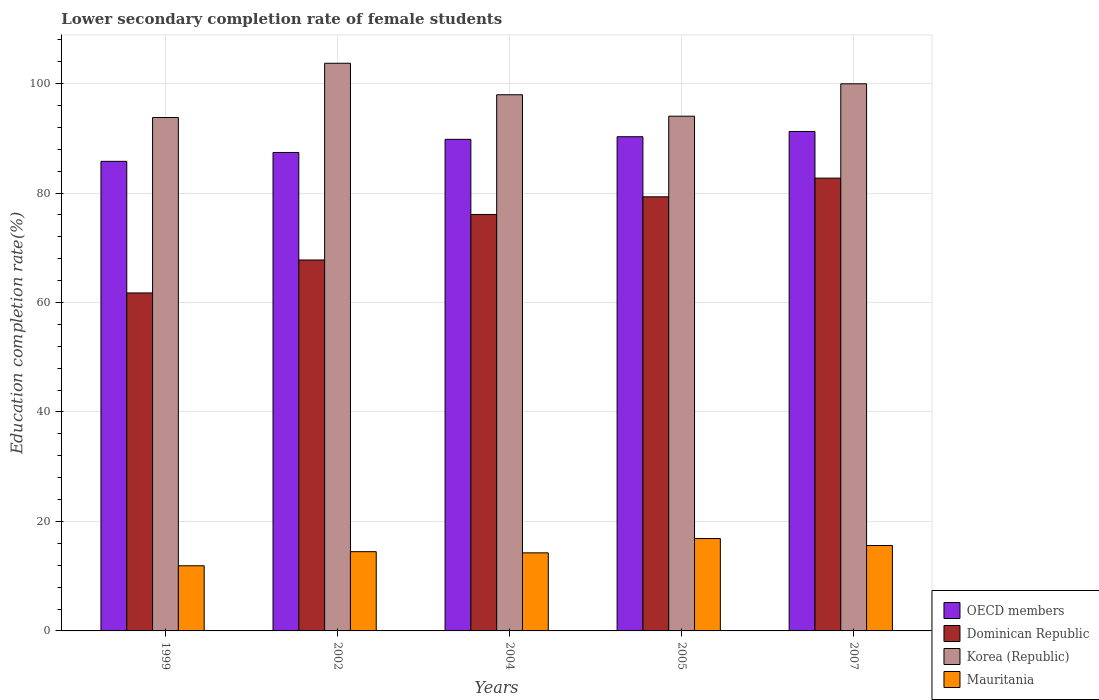Are the number of bars per tick equal to the number of legend labels?
Provide a short and direct response. Yes. How many bars are there on the 3rd tick from the left?
Your answer should be very brief. 4. How many bars are there on the 3rd tick from the right?
Give a very brief answer. 4. What is the label of the 1st group of bars from the left?
Your answer should be very brief. 1999. In how many cases, is the number of bars for a given year not equal to the number of legend labels?
Your response must be concise. 0. What is the lower secondary completion rate of female students in Korea (Republic) in 2005?
Your answer should be compact. 94.05. Across all years, what is the maximum lower secondary completion rate of female students in Mauritania?
Keep it short and to the point. 16.88. Across all years, what is the minimum lower secondary completion rate of female students in Mauritania?
Your answer should be compact. 11.9. What is the total lower secondary completion rate of female students in OECD members in the graph?
Give a very brief answer. 444.58. What is the difference between the lower secondary completion rate of female students in Mauritania in 1999 and that in 2004?
Keep it short and to the point. -2.36. What is the difference between the lower secondary completion rate of female students in Mauritania in 2005 and the lower secondary completion rate of female students in Dominican Republic in 1999?
Make the answer very short. -44.88. What is the average lower secondary completion rate of female students in OECD members per year?
Your response must be concise. 88.92. In the year 2007, what is the difference between the lower secondary completion rate of female students in Mauritania and lower secondary completion rate of female students in Dominican Republic?
Provide a succinct answer. -67.13. What is the ratio of the lower secondary completion rate of female students in Dominican Republic in 2002 to that in 2004?
Your response must be concise. 0.89. Is the lower secondary completion rate of female students in Korea (Republic) in 2002 less than that in 2007?
Ensure brevity in your answer.  No. What is the difference between the highest and the second highest lower secondary completion rate of female students in OECD members?
Offer a very short reply. 0.96. What is the difference between the highest and the lowest lower secondary completion rate of female students in Korea (Republic)?
Give a very brief answer. 9.91. What does the 1st bar from the left in 2002 represents?
Your response must be concise. OECD members. What does the 1st bar from the right in 2004 represents?
Provide a succinct answer. Mauritania. Are all the bars in the graph horizontal?
Your answer should be compact. No. How many years are there in the graph?
Offer a very short reply. 5. Are the values on the major ticks of Y-axis written in scientific E-notation?
Your answer should be very brief. No. Does the graph contain any zero values?
Provide a succinct answer. No. How many legend labels are there?
Give a very brief answer. 4. How are the legend labels stacked?
Offer a very short reply. Vertical. What is the title of the graph?
Provide a short and direct response. Lower secondary completion rate of female students. What is the label or title of the Y-axis?
Make the answer very short. Education completion rate(%). What is the Education completion rate(%) in OECD members in 1999?
Ensure brevity in your answer.  85.8. What is the Education completion rate(%) of Dominican Republic in 1999?
Ensure brevity in your answer.  61.75. What is the Education completion rate(%) of Korea (Republic) in 1999?
Give a very brief answer. 93.8. What is the Education completion rate(%) in Mauritania in 1999?
Ensure brevity in your answer.  11.9. What is the Education completion rate(%) of OECD members in 2002?
Make the answer very short. 87.42. What is the Education completion rate(%) of Dominican Republic in 2002?
Ensure brevity in your answer.  67.77. What is the Education completion rate(%) of Korea (Republic) in 2002?
Offer a very short reply. 103.72. What is the Education completion rate(%) of Mauritania in 2002?
Make the answer very short. 14.48. What is the Education completion rate(%) in OECD members in 2004?
Offer a terse response. 89.82. What is the Education completion rate(%) in Dominican Republic in 2004?
Your answer should be compact. 76.09. What is the Education completion rate(%) of Korea (Republic) in 2004?
Give a very brief answer. 97.96. What is the Education completion rate(%) in Mauritania in 2004?
Give a very brief answer. 14.26. What is the Education completion rate(%) of OECD members in 2005?
Provide a succinct answer. 90.29. What is the Education completion rate(%) of Dominican Republic in 2005?
Your answer should be compact. 79.31. What is the Education completion rate(%) of Korea (Republic) in 2005?
Your response must be concise. 94.05. What is the Education completion rate(%) in Mauritania in 2005?
Provide a short and direct response. 16.88. What is the Education completion rate(%) in OECD members in 2007?
Your answer should be compact. 91.25. What is the Education completion rate(%) of Dominican Republic in 2007?
Your answer should be compact. 82.73. What is the Education completion rate(%) in Korea (Republic) in 2007?
Provide a succinct answer. 99.96. What is the Education completion rate(%) in Mauritania in 2007?
Keep it short and to the point. 15.6. Across all years, what is the maximum Education completion rate(%) of OECD members?
Provide a short and direct response. 91.25. Across all years, what is the maximum Education completion rate(%) in Dominican Republic?
Your response must be concise. 82.73. Across all years, what is the maximum Education completion rate(%) of Korea (Republic)?
Your response must be concise. 103.72. Across all years, what is the maximum Education completion rate(%) of Mauritania?
Keep it short and to the point. 16.88. Across all years, what is the minimum Education completion rate(%) of OECD members?
Offer a very short reply. 85.8. Across all years, what is the minimum Education completion rate(%) of Dominican Republic?
Provide a succinct answer. 61.75. Across all years, what is the minimum Education completion rate(%) of Korea (Republic)?
Give a very brief answer. 93.8. Across all years, what is the minimum Education completion rate(%) in Mauritania?
Your response must be concise. 11.9. What is the total Education completion rate(%) of OECD members in the graph?
Your answer should be compact. 444.58. What is the total Education completion rate(%) of Dominican Republic in the graph?
Offer a terse response. 367.66. What is the total Education completion rate(%) in Korea (Republic) in the graph?
Your answer should be compact. 489.49. What is the total Education completion rate(%) in Mauritania in the graph?
Keep it short and to the point. 73.12. What is the difference between the Education completion rate(%) of OECD members in 1999 and that in 2002?
Give a very brief answer. -1.62. What is the difference between the Education completion rate(%) in Dominican Republic in 1999 and that in 2002?
Make the answer very short. -6.02. What is the difference between the Education completion rate(%) of Korea (Republic) in 1999 and that in 2002?
Keep it short and to the point. -9.91. What is the difference between the Education completion rate(%) in Mauritania in 1999 and that in 2002?
Keep it short and to the point. -2.58. What is the difference between the Education completion rate(%) in OECD members in 1999 and that in 2004?
Keep it short and to the point. -4.02. What is the difference between the Education completion rate(%) of Dominican Republic in 1999 and that in 2004?
Offer a very short reply. -14.34. What is the difference between the Education completion rate(%) in Korea (Republic) in 1999 and that in 2004?
Offer a very short reply. -4.16. What is the difference between the Education completion rate(%) of Mauritania in 1999 and that in 2004?
Ensure brevity in your answer.  -2.36. What is the difference between the Education completion rate(%) in OECD members in 1999 and that in 2005?
Your answer should be compact. -4.5. What is the difference between the Education completion rate(%) in Dominican Republic in 1999 and that in 2005?
Provide a succinct answer. -17.56. What is the difference between the Education completion rate(%) in Korea (Republic) in 1999 and that in 2005?
Give a very brief answer. -0.24. What is the difference between the Education completion rate(%) of Mauritania in 1999 and that in 2005?
Provide a succinct answer. -4.97. What is the difference between the Education completion rate(%) in OECD members in 1999 and that in 2007?
Ensure brevity in your answer.  -5.46. What is the difference between the Education completion rate(%) of Dominican Republic in 1999 and that in 2007?
Make the answer very short. -20.98. What is the difference between the Education completion rate(%) of Korea (Republic) in 1999 and that in 2007?
Your response must be concise. -6.16. What is the difference between the Education completion rate(%) of Mauritania in 1999 and that in 2007?
Give a very brief answer. -3.7. What is the difference between the Education completion rate(%) of OECD members in 2002 and that in 2004?
Give a very brief answer. -2.4. What is the difference between the Education completion rate(%) in Dominican Republic in 2002 and that in 2004?
Offer a very short reply. -8.32. What is the difference between the Education completion rate(%) in Korea (Republic) in 2002 and that in 2004?
Provide a succinct answer. 5.75. What is the difference between the Education completion rate(%) of Mauritania in 2002 and that in 2004?
Provide a short and direct response. 0.22. What is the difference between the Education completion rate(%) of OECD members in 2002 and that in 2005?
Offer a very short reply. -2.88. What is the difference between the Education completion rate(%) of Dominican Republic in 2002 and that in 2005?
Keep it short and to the point. -11.54. What is the difference between the Education completion rate(%) in Korea (Republic) in 2002 and that in 2005?
Keep it short and to the point. 9.67. What is the difference between the Education completion rate(%) in Mauritania in 2002 and that in 2005?
Your response must be concise. -2.4. What is the difference between the Education completion rate(%) of OECD members in 2002 and that in 2007?
Your answer should be very brief. -3.84. What is the difference between the Education completion rate(%) in Dominican Republic in 2002 and that in 2007?
Make the answer very short. -14.96. What is the difference between the Education completion rate(%) in Korea (Republic) in 2002 and that in 2007?
Ensure brevity in your answer.  3.75. What is the difference between the Education completion rate(%) in Mauritania in 2002 and that in 2007?
Your answer should be very brief. -1.12. What is the difference between the Education completion rate(%) of OECD members in 2004 and that in 2005?
Your answer should be compact. -0.48. What is the difference between the Education completion rate(%) in Dominican Republic in 2004 and that in 2005?
Give a very brief answer. -3.23. What is the difference between the Education completion rate(%) in Korea (Republic) in 2004 and that in 2005?
Your answer should be very brief. 3.92. What is the difference between the Education completion rate(%) of Mauritania in 2004 and that in 2005?
Your answer should be compact. -2.61. What is the difference between the Education completion rate(%) in OECD members in 2004 and that in 2007?
Your answer should be compact. -1.44. What is the difference between the Education completion rate(%) in Dominican Republic in 2004 and that in 2007?
Offer a terse response. -6.64. What is the difference between the Education completion rate(%) of Korea (Republic) in 2004 and that in 2007?
Keep it short and to the point. -2. What is the difference between the Education completion rate(%) in Mauritania in 2004 and that in 2007?
Your response must be concise. -1.34. What is the difference between the Education completion rate(%) of OECD members in 2005 and that in 2007?
Your response must be concise. -0.96. What is the difference between the Education completion rate(%) of Dominican Republic in 2005 and that in 2007?
Your answer should be compact. -3.42. What is the difference between the Education completion rate(%) in Korea (Republic) in 2005 and that in 2007?
Ensure brevity in your answer.  -5.92. What is the difference between the Education completion rate(%) in Mauritania in 2005 and that in 2007?
Make the answer very short. 1.27. What is the difference between the Education completion rate(%) of OECD members in 1999 and the Education completion rate(%) of Dominican Republic in 2002?
Offer a very short reply. 18.02. What is the difference between the Education completion rate(%) in OECD members in 1999 and the Education completion rate(%) in Korea (Republic) in 2002?
Keep it short and to the point. -17.92. What is the difference between the Education completion rate(%) of OECD members in 1999 and the Education completion rate(%) of Mauritania in 2002?
Give a very brief answer. 71.32. What is the difference between the Education completion rate(%) of Dominican Republic in 1999 and the Education completion rate(%) of Korea (Republic) in 2002?
Give a very brief answer. -41.96. What is the difference between the Education completion rate(%) in Dominican Republic in 1999 and the Education completion rate(%) in Mauritania in 2002?
Ensure brevity in your answer.  47.27. What is the difference between the Education completion rate(%) in Korea (Republic) in 1999 and the Education completion rate(%) in Mauritania in 2002?
Your answer should be compact. 79.32. What is the difference between the Education completion rate(%) in OECD members in 1999 and the Education completion rate(%) in Dominican Republic in 2004?
Offer a terse response. 9.71. What is the difference between the Education completion rate(%) in OECD members in 1999 and the Education completion rate(%) in Korea (Republic) in 2004?
Offer a very short reply. -12.17. What is the difference between the Education completion rate(%) of OECD members in 1999 and the Education completion rate(%) of Mauritania in 2004?
Provide a short and direct response. 71.53. What is the difference between the Education completion rate(%) in Dominican Republic in 1999 and the Education completion rate(%) in Korea (Republic) in 2004?
Ensure brevity in your answer.  -36.21. What is the difference between the Education completion rate(%) in Dominican Republic in 1999 and the Education completion rate(%) in Mauritania in 2004?
Your response must be concise. 47.49. What is the difference between the Education completion rate(%) in Korea (Republic) in 1999 and the Education completion rate(%) in Mauritania in 2004?
Give a very brief answer. 79.54. What is the difference between the Education completion rate(%) in OECD members in 1999 and the Education completion rate(%) in Dominican Republic in 2005?
Offer a terse response. 6.48. What is the difference between the Education completion rate(%) of OECD members in 1999 and the Education completion rate(%) of Korea (Republic) in 2005?
Provide a succinct answer. -8.25. What is the difference between the Education completion rate(%) in OECD members in 1999 and the Education completion rate(%) in Mauritania in 2005?
Ensure brevity in your answer.  68.92. What is the difference between the Education completion rate(%) in Dominican Republic in 1999 and the Education completion rate(%) in Korea (Republic) in 2005?
Offer a very short reply. -32.29. What is the difference between the Education completion rate(%) in Dominican Republic in 1999 and the Education completion rate(%) in Mauritania in 2005?
Ensure brevity in your answer.  44.88. What is the difference between the Education completion rate(%) in Korea (Republic) in 1999 and the Education completion rate(%) in Mauritania in 2005?
Your answer should be compact. 76.93. What is the difference between the Education completion rate(%) in OECD members in 1999 and the Education completion rate(%) in Dominican Republic in 2007?
Keep it short and to the point. 3.07. What is the difference between the Education completion rate(%) of OECD members in 1999 and the Education completion rate(%) of Korea (Republic) in 2007?
Ensure brevity in your answer.  -14.17. What is the difference between the Education completion rate(%) in OECD members in 1999 and the Education completion rate(%) in Mauritania in 2007?
Provide a short and direct response. 70.19. What is the difference between the Education completion rate(%) in Dominican Republic in 1999 and the Education completion rate(%) in Korea (Republic) in 2007?
Make the answer very short. -38.21. What is the difference between the Education completion rate(%) in Dominican Republic in 1999 and the Education completion rate(%) in Mauritania in 2007?
Keep it short and to the point. 46.15. What is the difference between the Education completion rate(%) of Korea (Republic) in 1999 and the Education completion rate(%) of Mauritania in 2007?
Your response must be concise. 78.2. What is the difference between the Education completion rate(%) of OECD members in 2002 and the Education completion rate(%) of Dominican Republic in 2004?
Your answer should be compact. 11.33. What is the difference between the Education completion rate(%) in OECD members in 2002 and the Education completion rate(%) in Korea (Republic) in 2004?
Your response must be concise. -10.55. What is the difference between the Education completion rate(%) of OECD members in 2002 and the Education completion rate(%) of Mauritania in 2004?
Give a very brief answer. 73.15. What is the difference between the Education completion rate(%) in Dominican Republic in 2002 and the Education completion rate(%) in Korea (Republic) in 2004?
Ensure brevity in your answer.  -30.19. What is the difference between the Education completion rate(%) of Dominican Republic in 2002 and the Education completion rate(%) of Mauritania in 2004?
Offer a terse response. 53.51. What is the difference between the Education completion rate(%) in Korea (Republic) in 2002 and the Education completion rate(%) in Mauritania in 2004?
Offer a terse response. 89.45. What is the difference between the Education completion rate(%) of OECD members in 2002 and the Education completion rate(%) of Dominican Republic in 2005?
Offer a terse response. 8.1. What is the difference between the Education completion rate(%) in OECD members in 2002 and the Education completion rate(%) in Korea (Republic) in 2005?
Make the answer very short. -6.63. What is the difference between the Education completion rate(%) in OECD members in 2002 and the Education completion rate(%) in Mauritania in 2005?
Provide a succinct answer. 70.54. What is the difference between the Education completion rate(%) of Dominican Republic in 2002 and the Education completion rate(%) of Korea (Republic) in 2005?
Provide a succinct answer. -26.27. What is the difference between the Education completion rate(%) of Dominican Republic in 2002 and the Education completion rate(%) of Mauritania in 2005?
Keep it short and to the point. 50.9. What is the difference between the Education completion rate(%) of Korea (Republic) in 2002 and the Education completion rate(%) of Mauritania in 2005?
Provide a short and direct response. 86.84. What is the difference between the Education completion rate(%) of OECD members in 2002 and the Education completion rate(%) of Dominican Republic in 2007?
Your answer should be very brief. 4.69. What is the difference between the Education completion rate(%) in OECD members in 2002 and the Education completion rate(%) in Korea (Republic) in 2007?
Your response must be concise. -12.55. What is the difference between the Education completion rate(%) in OECD members in 2002 and the Education completion rate(%) in Mauritania in 2007?
Your response must be concise. 71.82. What is the difference between the Education completion rate(%) in Dominican Republic in 2002 and the Education completion rate(%) in Korea (Republic) in 2007?
Your answer should be compact. -32.19. What is the difference between the Education completion rate(%) of Dominican Republic in 2002 and the Education completion rate(%) of Mauritania in 2007?
Provide a succinct answer. 52.17. What is the difference between the Education completion rate(%) in Korea (Republic) in 2002 and the Education completion rate(%) in Mauritania in 2007?
Provide a short and direct response. 88.12. What is the difference between the Education completion rate(%) in OECD members in 2004 and the Education completion rate(%) in Dominican Republic in 2005?
Give a very brief answer. 10.5. What is the difference between the Education completion rate(%) of OECD members in 2004 and the Education completion rate(%) of Korea (Republic) in 2005?
Provide a succinct answer. -4.23. What is the difference between the Education completion rate(%) in OECD members in 2004 and the Education completion rate(%) in Mauritania in 2005?
Ensure brevity in your answer.  72.94. What is the difference between the Education completion rate(%) in Dominican Republic in 2004 and the Education completion rate(%) in Korea (Republic) in 2005?
Offer a terse response. -17.96. What is the difference between the Education completion rate(%) in Dominican Republic in 2004 and the Education completion rate(%) in Mauritania in 2005?
Your answer should be very brief. 59.21. What is the difference between the Education completion rate(%) in Korea (Republic) in 2004 and the Education completion rate(%) in Mauritania in 2005?
Offer a terse response. 81.09. What is the difference between the Education completion rate(%) in OECD members in 2004 and the Education completion rate(%) in Dominican Republic in 2007?
Your answer should be compact. 7.09. What is the difference between the Education completion rate(%) of OECD members in 2004 and the Education completion rate(%) of Korea (Republic) in 2007?
Your answer should be very brief. -10.15. What is the difference between the Education completion rate(%) of OECD members in 2004 and the Education completion rate(%) of Mauritania in 2007?
Provide a short and direct response. 74.21. What is the difference between the Education completion rate(%) in Dominican Republic in 2004 and the Education completion rate(%) in Korea (Republic) in 2007?
Make the answer very short. -23.87. What is the difference between the Education completion rate(%) in Dominican Republic in 2004 and the Education completion rate(%) in Mauritania in 2007?
Provide a succinct answer. 60.49. What is the difference between the Education completion rate(%) in Korea (Republic) in 2004 and the Education completion rate(%) in Mauritania in 2007?
Make the answer very short. 82.36. What is the difference between the Education completion rate(%) of OECD members in 2005 and the Education completion rate(%) of Dominican Republic in 2007?
Provide a short and direct response. 7.56. What is the difference between the Education completion rate(%) in OECD members in 2005 and the Education completion rate(%) in Korea (Republic) in 2007?
Your answer should be compact. -9.67. What is the difference between the Education completion rate(%) of OECD members in 2005 and the Education completion rate(%) of Mauritania in 2007?
Offer a terse response. 74.69. What is the difference between the Education completion rate(%) in Dominican Republic in 2005 and the Education completion rate(%) in Korea (Republic) in 2007?
Your answer should be compact. -20.65. What is the difference between the Education completion rate(%) in Dominican Republic in 2005 and the Education completion rate(%) in Mauritania in 2007?
Offer a terse response. 63.71. What is the difference between the Education completion rate(%) of Korea (Republic) in 2005 and the Education completion rate(%) of Mauritania in 2007?
Offer a terse response. 78.44. What is the average Education completion rate(%) in OECD members per year?
Keep it short and to the point. 88.92. What is the average Education completion rate(%) in Dominican Republic per year?
Provide a short and direct response. 73.53. What is the average Education completion rate(%) in Korea (Republic) per year?
Your answer should be very brief. 97.9. What is the average Education completion rate(%) in Mauritania per year?
Provide a short and direct response. 14.62. In the year 1999, what is the difference between the Education completion rate(%) of OECD members and Education completion rate(%) of Dominican Republic?
Keep it short and to the point. 24.04. In the year 1999, what is the difference between the Education completion rate(%) of OECD members and Education completion rate(%) of Korea (Republic)?
Your answer should be compact. -8.01. In the year 1999, what is the difference between the Education completion rate(%) in OECD members and Education completion rate(%) in Mauritania?
Your response must be concise. 73.89. In the year 1999, what is the difference between the Education completion rate(%) in Dominican Republic and Education completion rate(%) in Korea (Republic)?
Offer a very short reply. -32.05. In the year 1999, what is the difference between the Education completion rate(%) of Dominican Republic and Education completion rate(%) of Mauritania?
Your response must be concise. 49.85. In the year 1999, what is the difference between the Education completion rate(%) in Korea (Republic) and Education completion rate(%) in Mauritania?
Offer a very short reply. 81.9. In the year 2002, what is the difference between the Education completion rate(%) of OECD members and Education completion rate(%) of Dominican Republic?
Provide a short and direct response. 19.65. In the year 2002, what is the difference between the Education completion rate(%) in OECD members and Education completion rate(%) in Korea (Republic)?
Make the answer very short. -16.3. In the year 2002, what is the difference between the Education completion rate(%) of OECD members and Education completion rate(%) of Mauritania?
Offer a terse response. 72.94. In the year 2002, what is the difference between the Education completion rate(%) in Dominican Republic and Education completion rate(%) in Korea (Republic)?
Ensure brevity in your answer.  -35.95. In the year 2002, what is the difference between the Education completion rate(%) in Dominican Republic and Education completion rate(%) in Mauritania?
Give a very brief answer. 53.29. In the year 2002, what is the difference between the Education completion rate(%) of Korea (Republic) and Education completion rate(%) of Mauritania?
Provide a succinct answer. 89.24. In the year 2004, what is the difference between the Education completion rate(%) of OECD members and Education completion rate(%) of Dominican Republic?
Your response must be concise. 13.73. In the year 2004, what is the difference between the Education completion rate(%) in OECD members and Education completion rate(%) in Korea (Republic)?
Offer a terse response. -8.15. In the year 2004, what is the difference between the Education completion rate(%) in OECD members and Education completion rate(%) in Mauritania?
Ensure brevity in your answer.  75.55. In the year 2004, what is the difference between the Education completion rate(%) of Dominican Republic and Education completion rate(%) of Korea (Republic)?
Your answer should be compact. -21.87. In the year 2004, what is the difference between the Education completion rate(%) in Dominican Republic and Education completion rate(%) in Mauritania?
Provide a short and direct response. 61.83. In the year 2004, what is the difference between the Education completion rate(%) in Korea (Republic) and Education completion rate(%) in Mauritania?
Your answer should be compact. 83.7. In the year 2005, what is the difference between the Education completion rate(%) of OECD members and Education completion rate(%) of Dominican Republic?
Offer a very short reply. 10.98. In the year 2005, what is the difference between the Education completion rate(%) of OECD members and Education completion rate(%) of Korea (Republic)?
Your response must be concise. -3.75. In the year 2005, what is the difference between the Education completion rate(%) in OECD members and Education completion rate(%) in Mauritania?
Offer a terse response. 73.42. In the year 2005, what is the difference between the Education completion rate(%) in Dominican Republic and Education completion rate(%) in Korea (Republic)?
Your response must be concise. -14.73. In the year 2005, what is the difference between the Education completion rate(%) of Dominican Republic and Education completion rate(%) of Mauritania?
Provide a short and direct response. 62.44. In the year 2005, what is the difference between the Education completion rate(%) of Korea (Republic) and Education completion rate(%) of Mauritania?
Provide a succinct answer. 77.17. In the year 2007, what is the difference between the Education completion rate(%) in OECD members and Education completion rate(%) in Dominican Republic?
Your answer should be compact. 8.52. In the year 2007, what is the difference between the Education completion rate(%) of OECD members and Education completion rate(%) of Korea (Republic)?
Offer a terse response. -8.71. In the year 2007, what is the difference between the Education completion rate(%) of OECD members and Education completion rate(%) of Mauritania?
Make the answer very short. 75.65. In the year 2007, what is the difference between the Education completion rate(%) in Dominican Republic and Education completion rate(%) in Korea (Republic)?
Your answer should be compact. -17.23. In the year 2007, what is the difference between the Education completion rate(%) of Dominican Republic and Education completion rate(%) of Mauritania?
Keep it short and to the point. 67.13. In the year 2007, what is the difference between the Education completion rate(%) of Korea (Republic) and Education completion rate(%) of Mauritania?
Your answer should be very brief. 84.36. What is the ratio of the Education completion rate(%) of OECD members in 1999 to that in 2002?
Provide a succinct answer. 0.98. What is the ratio of the Education completion rate(%) of Dominican Republic in 1999 to that in 2002?
Offer a very short reply. 0.91. What is the ratio of the Education completion rate(%) of Korea (Republic) in 1999 to that in 2002?
Offer a very short reply. 0.9. What is the ratio of the Education completion rate(%) of Mauritania in 1999 to that in 2002?
Keep it short and to the point. 0.82. What is the ratio of the Education completion rate(%) in OECD members in 1999 to that in 2004?
Ensure brevity in your answer.  0.96. What is the ratio of the Education completion rate(%) in Dominican Republic in 1999 to that in 2004?
Make the answer very short. 0.81. What is the ratio of the Education completion rate(%) of Korea (Republic) in 1999 to that in 2004?
Your answer should be compact. 0.96. What is the ratio of the Education completion rate(%) of Mauritania in 1999 to that in 2004?
Provide a short and direct response. 0.83. What is the ratio of the Education completion rate(%) of OECD members in 1999 to that in 2005?
Your response must be concise. 0.95. What is the ratio of the Education completion rate(%) of Dominican Republic in 1999 to that in 2005?
Provide a succinct answer. 0.78. What is the ratio of the Education completion rate(%) in Korea (Republic) in 1999 to that in 2005?
Give a very brief answer. 1. What is the ratio of the Education completion rate(%) in Mauritania in 1999 to that in 2005?
Keep it short and to the point. 0.71. What is the ratio of the Education completion rate(%) of OECD members in 1999 to that in 2007?
Give a very brief answer. 0.94. What is the ratio of the Education completion rate(%) of Dominican Republic in 1999 to that in 2007?
Give a very brief answer. 0.75. What is the ratio of the Education completion rate(%) in Korea (Republic) in 1999 to that in 2007?
Give a very brief answer. 0.94. What is the ratio of the Education completion rate(%) in Mauritania in 1999 to that in 2007?
Ensure brevity in your answer.  0.76. What is the ratio of the Education completion rate(%) of OECD members in 2002 to that in 2004?
Your answer should be very brief. 0.97. What is the ratio of the Education completion rate(%) of Dominican Republic in 2002 to that in 2004?
Provide a succinct answer. 0.89. What is the ratio of the Education completion rate(%) of Korea (Republic) in 2002 to that in 2004?
Your response must be concise. 1.06. What is the ratio of the Education completion rate(%) in Mauritania in 2002 to that in 2004?
Provide a short and direct response. 1.02. What is the ratio of the Education completion rate(%) in OECD members in 2002 to that in 2005?
Provide a short and direct response. 0.97. What is the ratio of the Education completion rate(%) in Dominican Republic in 2002 to that in 2005?
Your answer should be compact. 0.85. What is the ratio of the Education completion rate(%) of Korea (Republic) in 2002 to that in 2005?
Ensure brevity in your answer.  1.1. What is the ratio of the Education completion rate(%) of Mauritania in 2002 to that in 2005?
Provide a short and direct response. 0.86. What is the ratio of the Education completion rate(%) in OECD members in 2002 to that in 2007?
Make the answer very short. 0.96. What is the ratio of the Education completion rate(%) in Dominican Republic in 2002 to that in 2007?
Give a very brief answer. 0.82. What is the ratio of the Education completion rate(%) of Korea (Republic) in 2002 to that in 2007?
Give a very brief answer. 1.04. What is the ratio of the Education completion rate(%) of Mauritania in 2002 to that in 2007?
Ensure brevity in your answer.  0.93. What is the ratio of the Education completion rate(%) in Dominican Republic in 2004 to that in 2005?
Offer a very short reply. 0.96. What is the ratio of the Education completion rate(%) of Korea (Republic) in 2004 to that in 2005?
Provide a succinct answer. 1.04. What is the ratio of the Education completion rate(%) of Mauritania in 2004 to that in 2005?
Offer a very short reply. 0.85. What is the ratio of the Education completion rate(%) in OECD members in 2004 to that in 2007?
Your response must be concise. 0.98. What is the ratio of the Education completion rate(%) of Dominican Republic in 2004 to that in 2007?
Keep it short and to the point. 0.92. What is the ratio of the Education completion rate(%) of Korea (Republic) in 2004 to that in 2007?
Provide a succinct answer. 0.98. What is the ratio of the Education completion rate(%) of Mauritania in 2004 to that in 2007?
Give a very brief answer. 0.91. What is the ratio of the Education completion rate(%) of OECD members in 2005 to that in 2007?
Make the answer very short. 0.99. What is the ratio of the Education completion rate(%) in Dominican Republic in 2005 to that in 2007?
Your answer should be compact. 0.96. What is the ratio of the Education completion rate(%) in Korea (Republic) in 2005 to that in 2007?
Provide a short and direct response. 0.94. What is the ratio of the Education completion rate(%) of Mauritania in 2005 to that in 2007?
Give a very brief answer. 1.08. What is the difference between the highest and the second highest Education completion rate(%) of OECD members?
Your response must be concise. 0.96. What is the difference between the highest and the second highest Education completion rate(%) in Dominican Republic?
Give a very brief answer. 3.42. What is the difference between the highest and the second highest Education completion rate(%) of Korea (Republic)?
Ensure brevity in your answer.  3.75. What is the difference between the highest and the second highest Education completion rate(%) of Mauritania?
Your answer should be compact. 1.27. What is the difference between the highest and the lowest Education completion rate(%) of OECD members?
Give a very brief answer. 5.46. What is the difference between the highest and the lowest Education completion rate(%) in Dominican Republic?
Offer a terse response. 20.98. What is the difference between the highest and the lowest Education completion rate(%) of Korea (Republic)?
Keep it short and to the point. 9.91. What is the difference between the highest and the lowest Education completion rate(%) in Mauritania?
Your response must be concise. 4.97. 